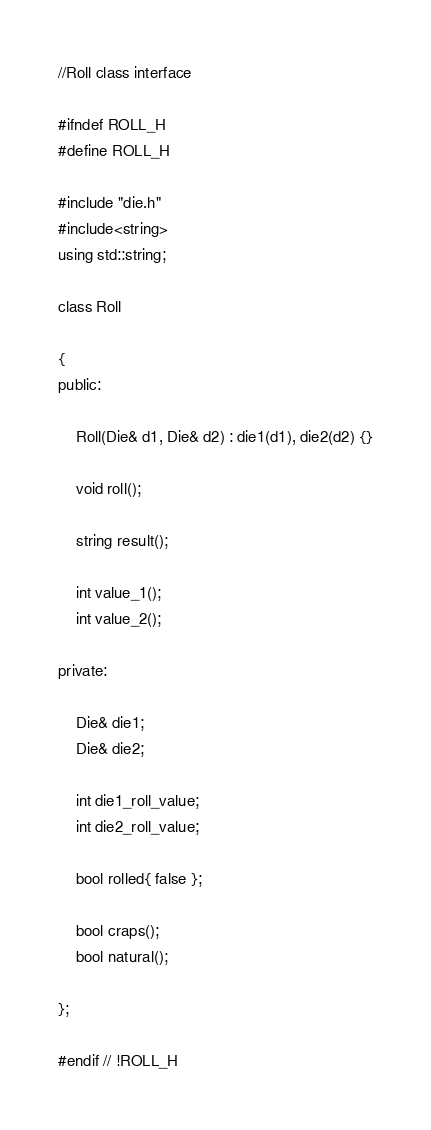Convert code to text. <code><loc_0><loc_0><loc_500><loc_500><_C_>//Roll class interface 

#ifndef ROLL_H
#define ROLL_H

#include "die.h"
#include<string>
using std::string;

class Roll

{
public:

	Roll(Die& d1, Die& d2) : die1(d1), die2(d2) {}

	void roll();

	string result();

	int value_1();
	int value_2();

private:

	Die& die1;
	Die& die2;

	int die1_roll_value;
	int die2_roll_value;

	bool rolled{ false };

	bool craps();
	bool natural();

};

#endif // !ROLL_H</code> 